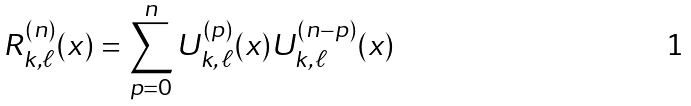Convert formula to latex. <formula><loc_0><loc_0><loc_500><loc_500>R _ { k , \ell } ^ { \left ( n \right ) } ( x ) = \sum _ { p = 0 } ^ { n } U _ { k , \, \ell } ^ { \left ( p \right ) } ( x ) U _ { k , \, \ell } ^ { \left ( n - p \right ) } ( x )</formula> 